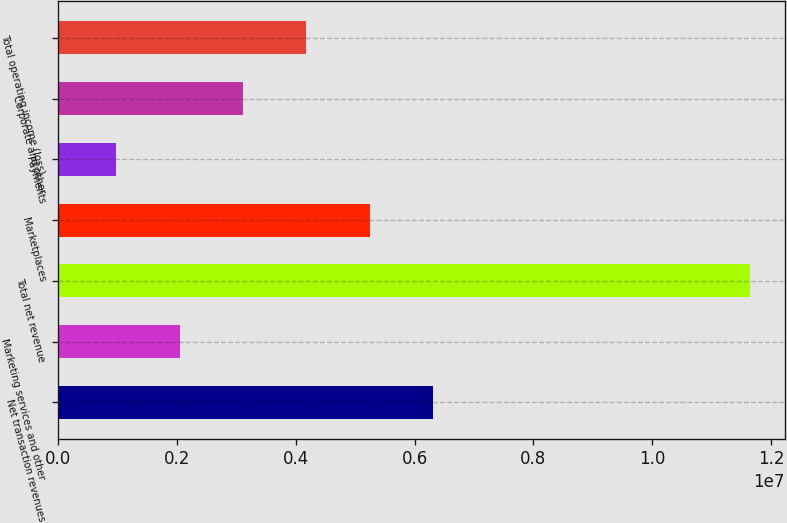Convert chart. <chart><loc_0><loc_0><loc_500><loc_500><bar_chart><fcel>Net transaction revenues<fcel>Marketing services and other<fcel>Total net revenue<fcel>Marketplaces<fcel>Payments<fcel>Corporate and other<fcel>Total operating income (loss)<nl><fcel>6.31485e+06<fcel>2.0454e+06<fcel>1.16517e+07<fcel>5.24749e+06<fcel>978042<fcel>3.11276e+06<fcel>4.18013e+06<nl></chart> 